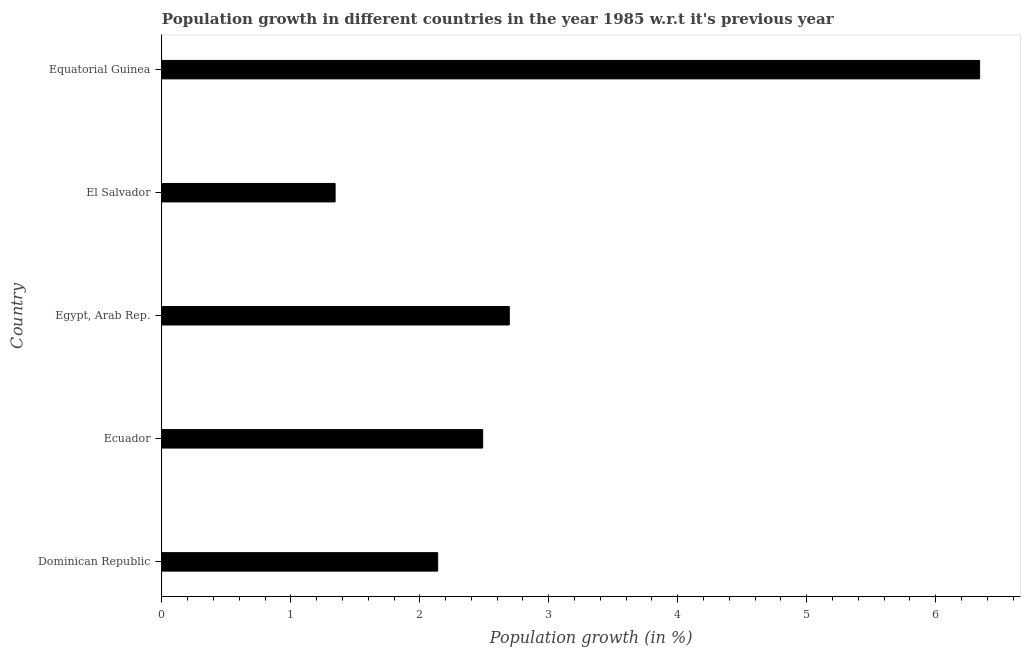Does the graph contain any zero values?
Provide a succinct answer. No. Does the graph contain grids?
Your answer should be compact. No. What is the title of the graph?
Provide a short and direct response. Population growth in different countries in the year 1985 w.r.t it's previous year. What is the label or title of the X-axis?
Make the answer very short. Population growth (in %). What is the label or title of the Y-axis?
Provide a succinct answer. Country. What is the population growth in Ecuador?
Ensure brevity in your answer.  2.49. Across all countries, what is the maximum population growth?
Your answer should be very brief. 6.34. Across all countries, what is the minimum population growth?
Your answer should be very brief. 1.34. In which country was the population growth maximum?
Keep it short and to the point. Equatorial Guinea. In which country was the population growth minimum?
Give a very brief answer. El Salvador. What is the sum of the population growth?
Provide a short and direct response. 15. What is the difference between the population growth in Egypt, Arab Rep. and El Salvador?
Your response must be concise. 1.35. What is the average population growth per country?
Ensure brevity in your answer.  3. What is the median population growth?
Your answer should be very brief. 2.49. In how many countries, is the population growth greater than 5.8 %?
Your answer should be compact. 1. What is the ratio of the population growth in El Salvador to that in Equatorial Guinea?
Offer a very short reply. 0.21. What is the difference between the highest and the second highest population growth?
Provide a short and direct response. 3.65. Is the sum of the population growth in Ecuador and El Salvador greater than the maximum population growth across all countries?
Provide a succinct answer. No. What is the difference between the highest and the lowest population growth?
Offer a very short reply. 5. How many bars are there?
Offer a terse response. 5. Are all the bars in the graph horizontal?
Keep it short and to the point. Yes. How many countries are there in the graph?
Your answer should be compact. 5. What is the Population growth (in %) of Dominican Republic?
Make the answer very short. 2.14. What is the Population growth (in %) of Ecuador?
Your response must be concise. 2.49. What is the Population growth (in %) of Egypt, Arab Rep.?
Your answer should be very brief. 2.69. What is the Population growth (in %) in El Salvador?
Offer a terse response. 1.34. What is the Population growth (in %) of Equatorial Guinea?
Provide a short and direct response. 6.34. What is the difference between the Population growth (in %) in Dominican Republic and Ecuador?
Provide a succinct answer. -0.35. What is the difference between the Population growth (in %) in Dominican Republic and Egypt, Arab Rep.?
Ensure brevity in your answer.  -0.56. What is the difference between the Population growth (in %) in Dominican Republic and El Salvador?
Offer a very short reply. 0.8. What is the difference between the Population growth (in %) in Dominican Republic and Equatorial Guinea?
Give a very brief answer. -4.2. What is the difference between the Population growth (in %) in Ecuador and Egypt, Arab Rep.?
Provide a succinct answer. -0.21. What is the difference between the Population growth (in %) in Ecuador and El Salvador?
Provide a succinct answer. 1.14. What is the difference between the Population growth (in %) in Ecuador and Equatorial Guinea?
Offer a terse response. -3.85. What is the difference between the Population growth (in %) in Egypt, Arab Rep. and El Salvador?
Ensure brevity in your answer.  1.35. What is the difference between the Population growth (in %) in Egypt, Arab Rep. and Equatorial Guinea?
Your answer should be very brief. -3.65. What is the difference between the Population growth (in %) in El Salvador and Equatorial Guinea?
Make the answer very short. -5. What is the ratio of the Population growth (in %) in Dominican Republic to that in Ecuador?
Give a very brief answer. 0.86. What is the ratio of the Population growth (in %) in Dominican Republic to that in Egypt, Arab Rep.?
Give a very brief answer. 0.79. What is the ratio of the Population growth (in %) in Dominican Republic to that in El Salvador?
Ensure brevity in your answer.  1.59. What is the ratio of the Population growth (in %) in Dominican Republic to that in Equatorial Guinea?
Make the answer very short. 0.34. What is the ratio of the Population growth (in %) in Ecuador to that in Egypt, Arab Rep.?
Offer a very short reply. 0.92. What is the ratio of the Population growth (in %) in Ecuador to that in El Salvador?
Your answer should be very brief. 1.85. What is the ratio of the Population growth (in %) in Ecuador to that in Equatorial Guinea?
Your answer should be compact. 0.39. What is the ratio of the Population growth (in %) in Egypt, Arab Rep. to that in El Salvador?
Give a very brief answer. 2.01. What is the ratio of the Population growth (in %) in Egypt, Arab Rep. to that in Equatorial Guinea?
Your answer should be very brief. 0.42. What is the ratio of the Population growth (in %) in El Salvador to that in Equatorial Guinea?
Ensure brevity in your answer.  0.21. 